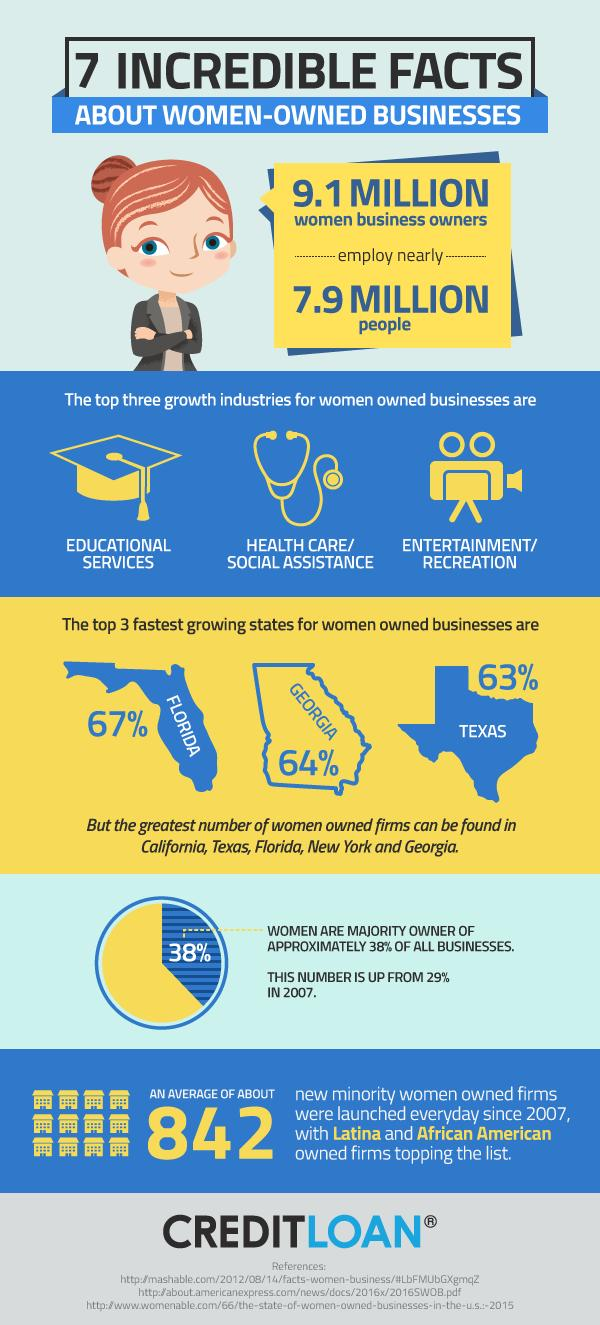Draw attention to some important aspects in this diagram. According to data, Florida, Georgia, and Texas are among the top three states in the United States that support and encourage the growth of women-owned businesses. According to a statistic, over 60% of businesses are owned by men. The highest percentage of women-owned businesses in the US is 67%. The percentage increase of firms owned by women from 2007 to 2015 was 9%. 